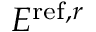<formula> <loc_0><loc_0><loc_500><loc_500>E ^ { r e f , r }</formula> 